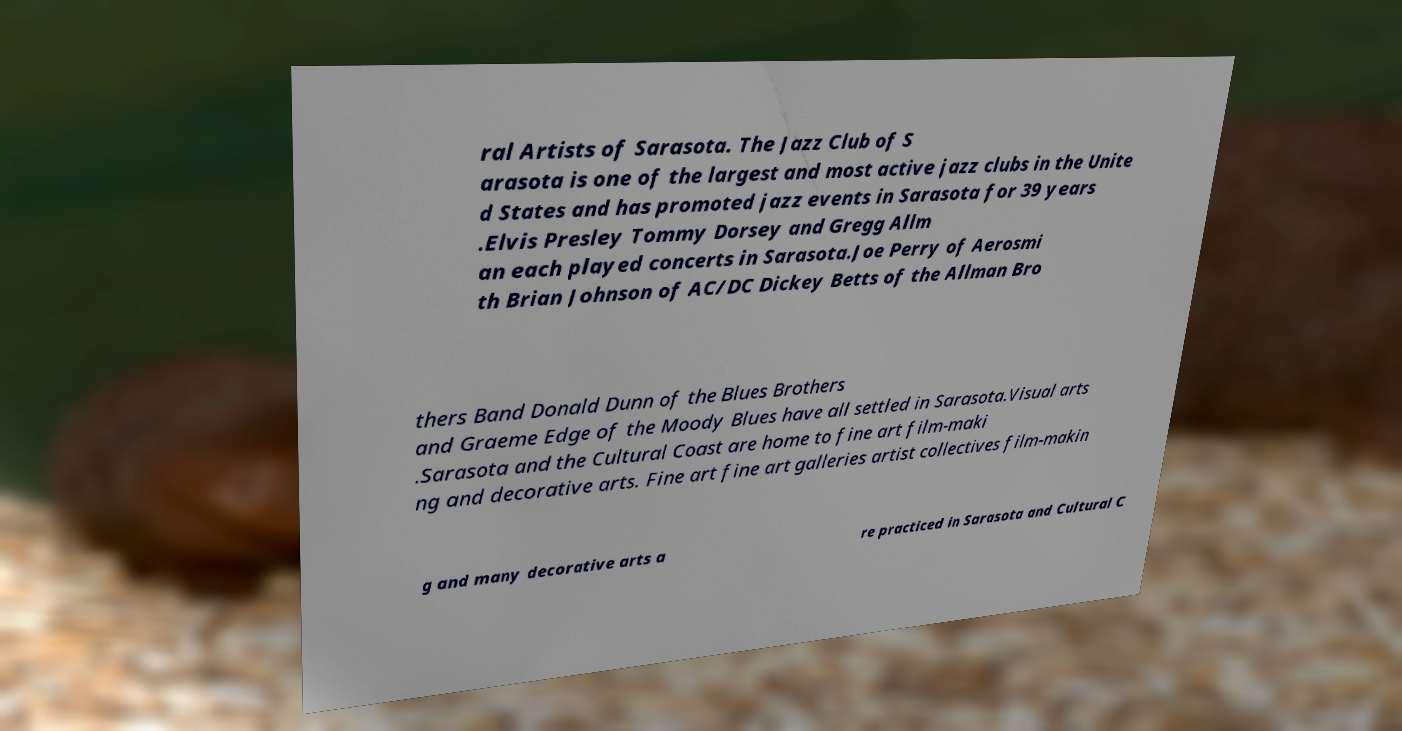Please read and relay the text visible in this image. What does it say? ral Artists of Sarasota. The Jazz Club of S arasota is one of the largest and most active jazz clubs in the Unite d States and has promoted jazz events in Sarasota for 39 years .Elvis Presley Tommy Dorsey and Gregg Allm an each played concerts in Sarasota.Joe Perry of Aerosmi th Brian Johnson of AC/DC Dickey Betts of the Allman Bro thers Band Donald Dunn of the Blues Brothers and Graeme Edge of the Moody Blues have all settled in Sarasota.Visual arts .Sarasota and the Cultural Coast are home to fine art film-maki ng and decorative arts. Fine art fine art galleries artist collectives film-makin g and many decorative arts a re practiced in Sarasota and Cultural C 